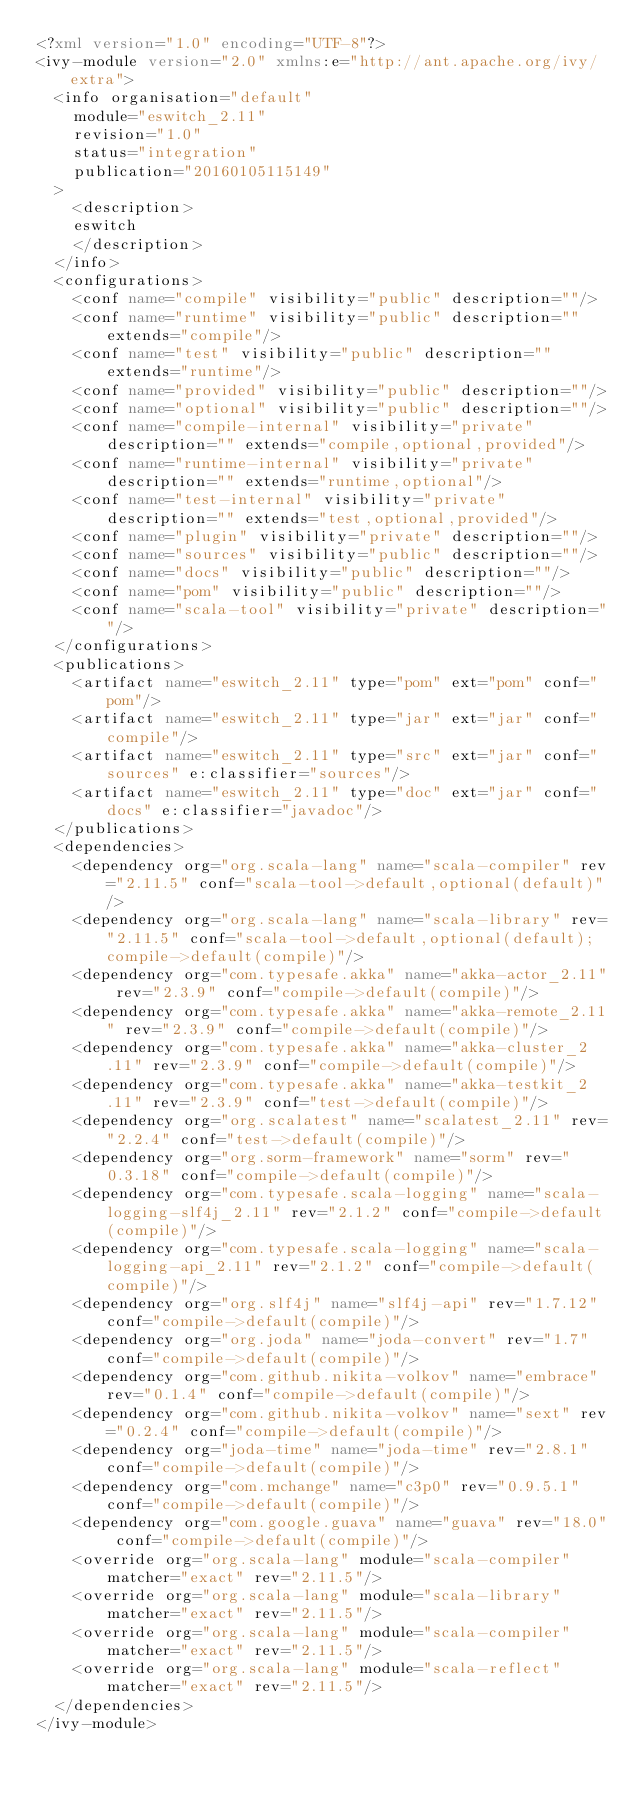<code> <loc_0><loc_0><loc_500><loc_500><_XML_><?xml version="1.0" encoding="UTF-8"?>
<ivy-module version="2.0" xmlns:e="http://ant.apache.org/ivy/extra">
	<info organisation="default"
		module="eswitch_2.11"
		revision="1.0"
		status="integration"
		publication="20160105115149"
	>
		<description>
		eswitch
		</description>
	</info>
	<configurations>
		<conf name="compile" visibility="public" description=""/>
		<conf name="runtime" visibility="public" description="" extends="compile"/>
		<conf name="test" visibility="public" description="" extends="runtime"/>
		<conf name="provided" visibility="public" description=""/>
		<conf name="optional" visibility="public" description=""/>
		<conf name="compile-internal" visibility="private" description="" extends="compile,optional,provided"/>
		<conf name="runtime-internal" visibility="private" description="" extends="runtime,optional"/>
		<conf name="test-internal" visibility="private" description="" extends="test,optional,provided"/>
		<conf name="plugin" visibility="private" description=""/>
		<conf name="sources" visibility="public" description=""/>
		<conf name="docs" visibility="public" description=""/>
		<conf name="pom" visibility="public" description=""/>
		<conf name="scala-tool" visibility="private" description=""/>
	</configurations>
	<publications>
		<artifact name="eswitch_2.11" type="pom" ext="pom" conf="pom"/>
		<artifact name="eswitch_2.11" type="jar" ext="jar" conf="compile"/>
		<artifact name="eswitch_2.11" type="src" ext="jar" conf="sources" e:classifier="sources"/>
		<artifact name="eswitch_2.11" type="doc" ext="jar" conf="docs" e:classifier="javadoc"/>
	</publications>
	<dependencies>
		<dependency org="org.scala-lang" name="scala-compiler" rev="2.11.5" conf="scala-tool->default,optional(default)"/>
		<dependency org="org.scala-lang" name="scala-library" rev="2.11.5" conf="scala-tool->default,optional(default);compile->default(compile)"/>
		<dependency org="com.typesafe.akka" name="akka-actor_2.11" rev="2.3.9" conf="compile->default(compile)"/>
		<dependency org="com.typesafe.akka" name="akka-remote_2.11" rev="2.3.9" conf="compile->default(compile)"/>
		<dependency org="com.typesafe.akka" name="akka-cluster_2.11" rev="2.3.9" conf="compile->default(compile)"/>
		<dependency org="com.typesafe.akka" name="akka-testkit_2.11" rev="2.3.9" conf="test->default(compile)"/>
		<dependency org="org.scalatest" name="scalatest_2.11" rev="2.2.4" conf="test->default(compile)"/>
		<dependency org="org.sorm-framework" name="sorm" rev="0.3.18" conf="compile->default(compile)"/>
		<dependency org="com.typesafe.scala-logging" name="scala-logging-slf4j_2.11" rev="2.1.2" conf="compile->default(compile)"/>
		<dependency org="com.typesafe.scala-logging" name="scala-logging-api_2.11" rev="2.1.2" conf="compile->default(compile)"/>
		<dependency org="org.slf4j" name="slf4j-api" rev="1.7.12" conf="compile->default(compile)"/>
		<dependency org="org.joda" name="joda-convert" rev="1.7" conf="compile->default(compile)"/>
		<dependency org="com.github.nikita-volkov" name="embrace" rev="0.1.4" conf="compile->default(compile)"/>
		<dependency org="com.github.nikita-volkov" name="sext" rev="0.2.4" conf="compile->default(compile)"/>
		<dependency org="joda-time" name="joda-time" rev="2.8.1" conf="compile->default(compile)"/>
		<dependency org="com.mchange" name="c3p0" rev="0.9.5.1" conf="compile->default(compile)"/>
		<dependency org="com.google.guava" name="guava" rev="18.0" conf="compile->default(compile)"/>
		<override org="org.scala-lang" module="scala-compiler" matcher="exact" rev="2.11.5"/>
		<override org="org.scala-lang" module="scala-library" matcher="exact" rev="2.11.5"/>
		<override org="org.scala-lang" module="scala-compiler" matcher="exact" rev="2.11.5"/>
		<override org="org.scala-lang" module="scala-reflect" matcher="exact" rev="2.11.5"/>
	</dependencies>
</ivy-module>
</code> 